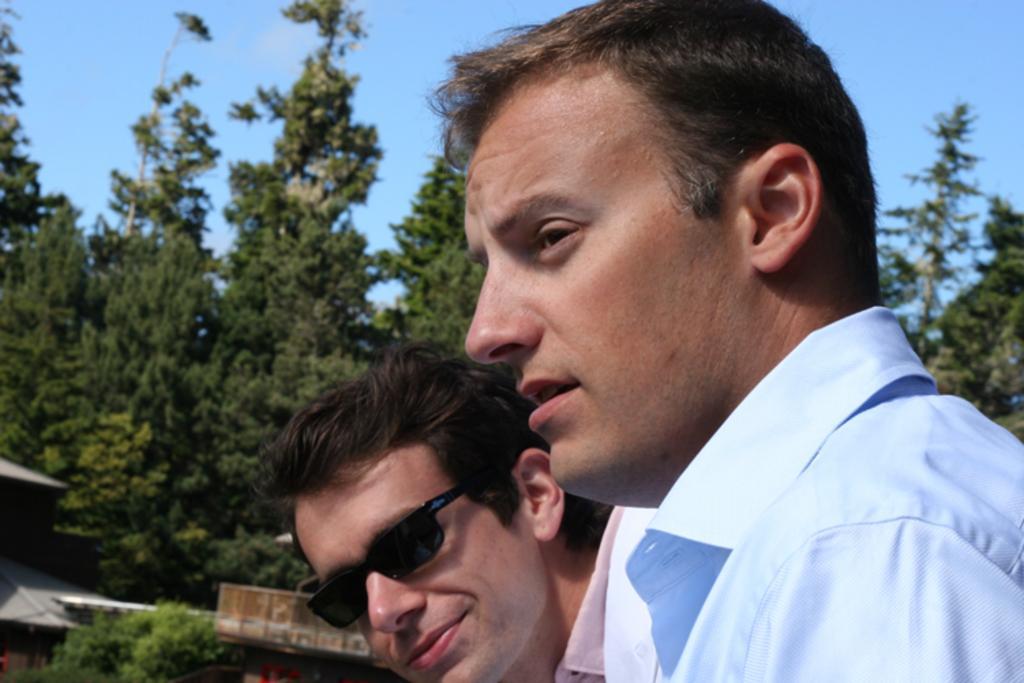Describe this image in one or two sentences. In this image in the foreground there are two people one person is wearing goggles, and in the background there are some trees and houses. At the top there is sky. 